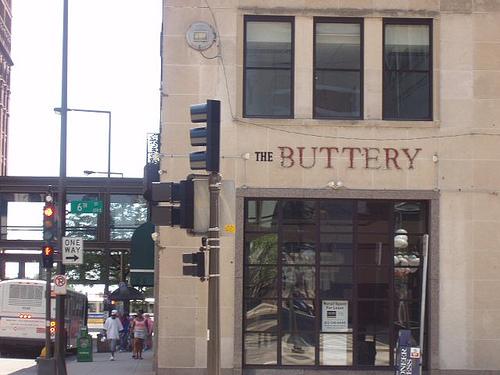What is the name of the business?
Write a very short answer. Buttery. How many people are in this picture?
Keep it brief. 3. What color are the windows?
Answer briefly. Black. What is the purpose of the building?
Quick response, please. Food. How many phones are in the image?
Quick response, please. 0. Is this nighttime?
Answer briefly. No. What is the name on the building?
Concise answer only. Buttery. What is the building made of?
Quick response, please. Concrete. Is the traffic light turning red?
Give a very brief answer. Yes. What language are the signs in?
Write a very short answer. English. 